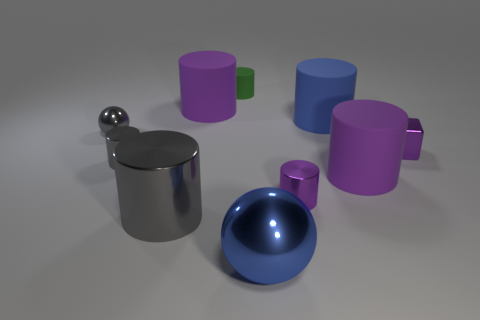Can you describe the different shapes and colors visible in this image? Certainly! The image presents a variety of geometric shapes. We see several cylinders: two are purple, one is blue, and one is green. There's also a silver sphere and what appears to be a shiny, metallic cylindrical container with a handle. Color-wise, we've got the diversity of purple, blue, green, and metallic silver. 